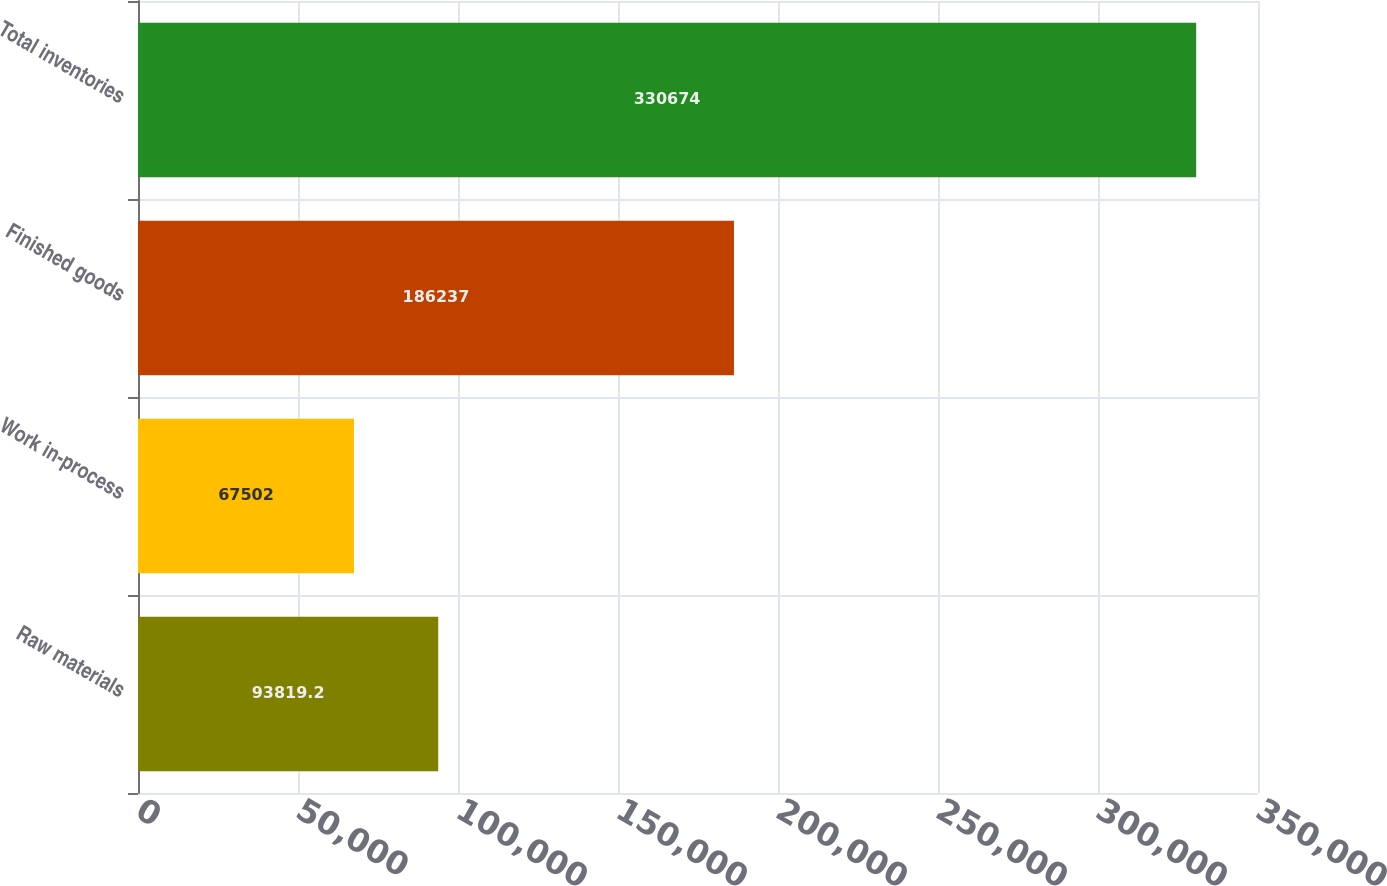<chart> <loc_0><loc_0><loc_500><loc_500><bar_chart><fcel>Raw materials<fcel>Work in-process<fcel>Finished goods<fcel>Total inventories<nl><fcel>93819.2<fcel>67502<fcel>186237<fcel>330674<nl></chart> 